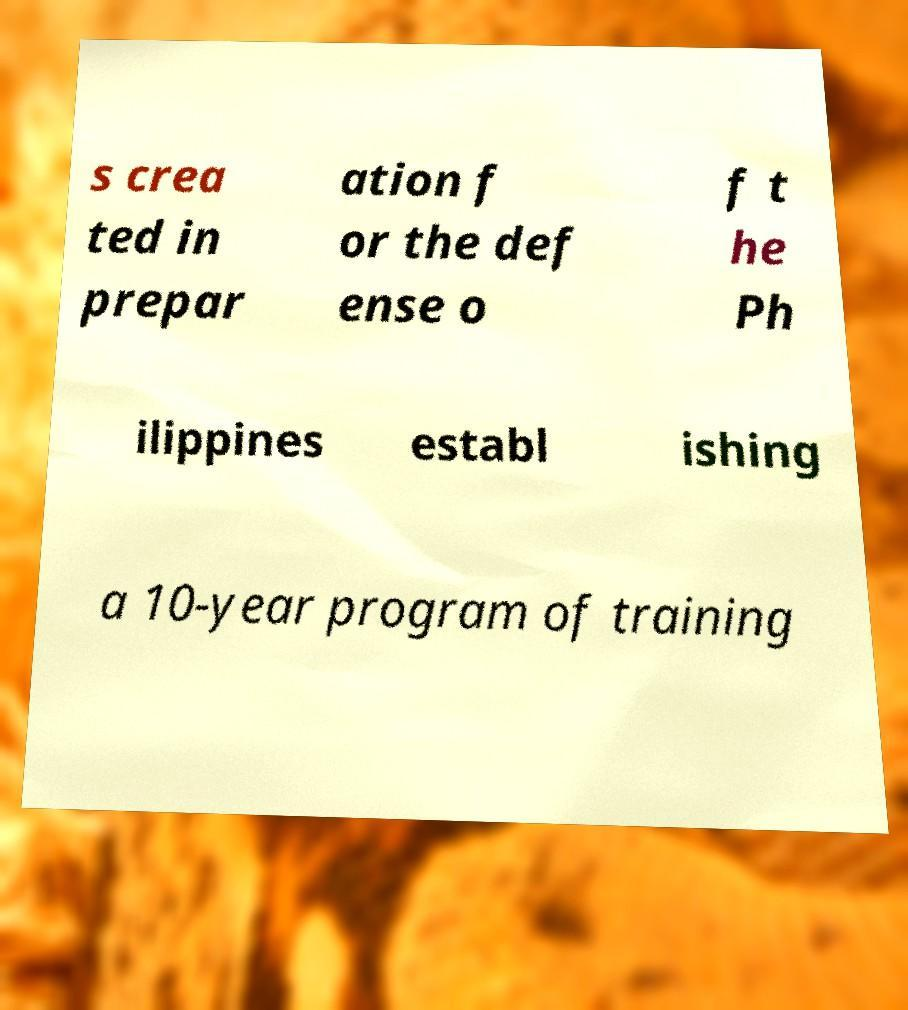There's text embedded in this image that I need extracted. Can you transcribe it verbatim? s crea ted in prepar ation f or the def ense o f t he Ph ilippines establ ishing a 10-year program of training 